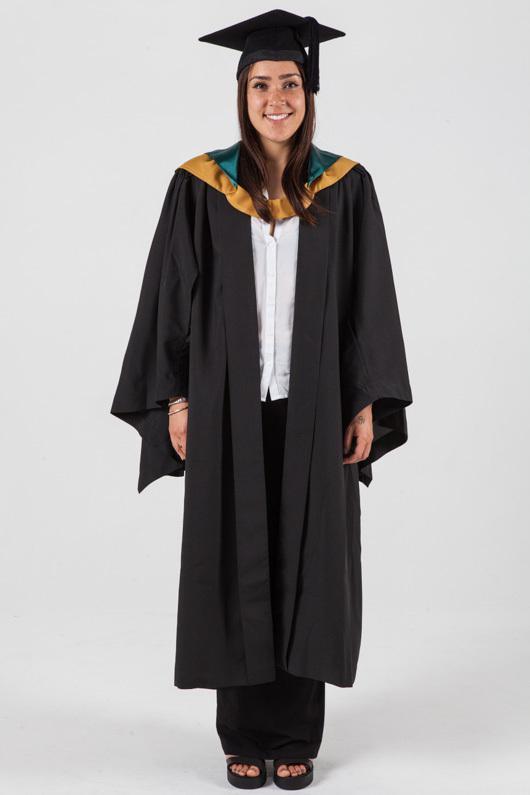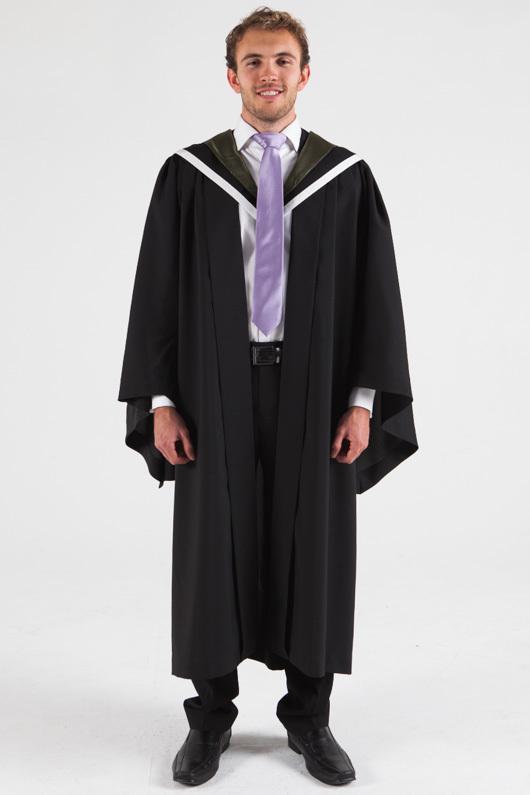The first image is the image on the left, the second image is the image on the right. Examine the images to the left and right. Is the description "There are exactly two people in the image on the right." accurate? Answer yes or no. No. The first image is the image on the left, the second image is the image on the right. Examine the images to the left and right. Is the description "An image shows front and rear views of a graduation model." accurate? Answer yes or no. No. 